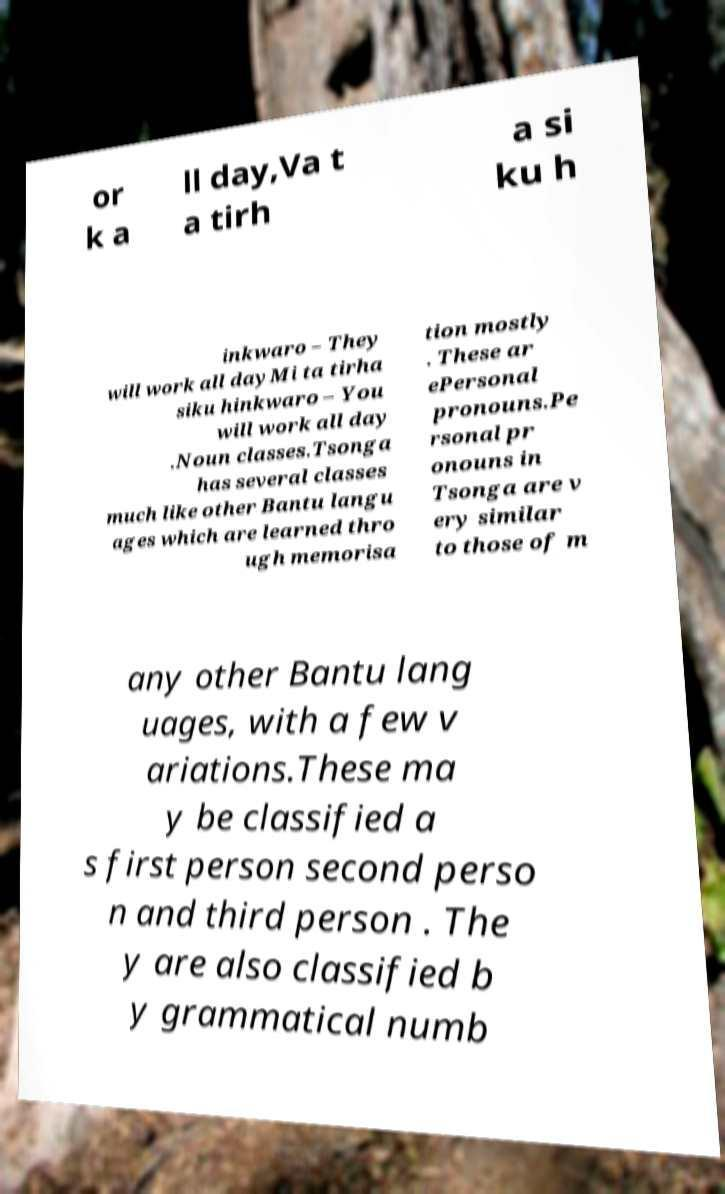Could you assist in decoding the text presented in this image and type it out clearly? or k a ll day,Va t a tirh a si ku h inkwaro – They will work all dayMi ta tirha siku hinkwaro – You will work all day .Noun classes.Tsonga has several classes much like other Bantu langu ages which are learned thro ugh memorisa tion mostly . These ar ePersonal pronouns.Pe rsonal pr onouns in Tsonga are v ery similar to those of m any other Bantu lang uages, with a few v ariations.These ma y be classified a s first person second perso n and third person . The y are also classified b y grammatical numb 